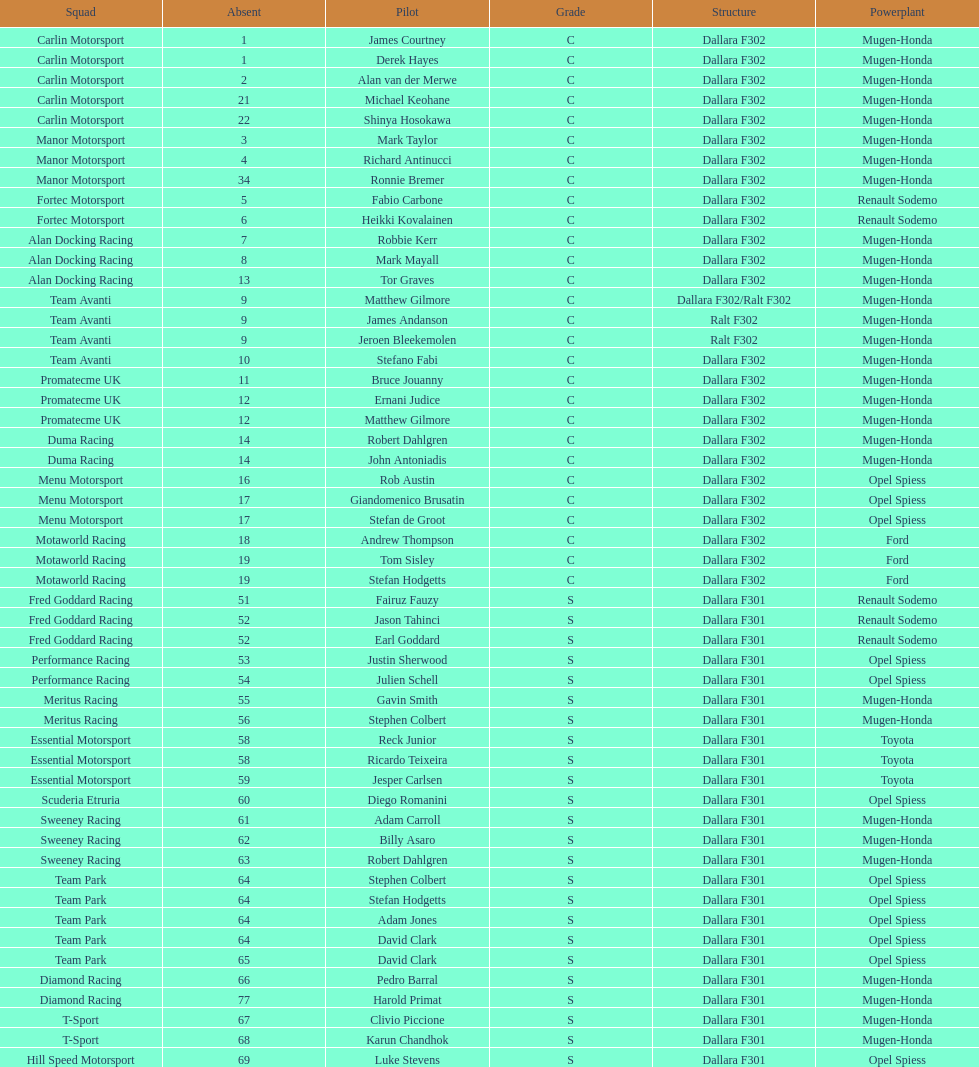What is the total number of class c (championship) teams? 21. 